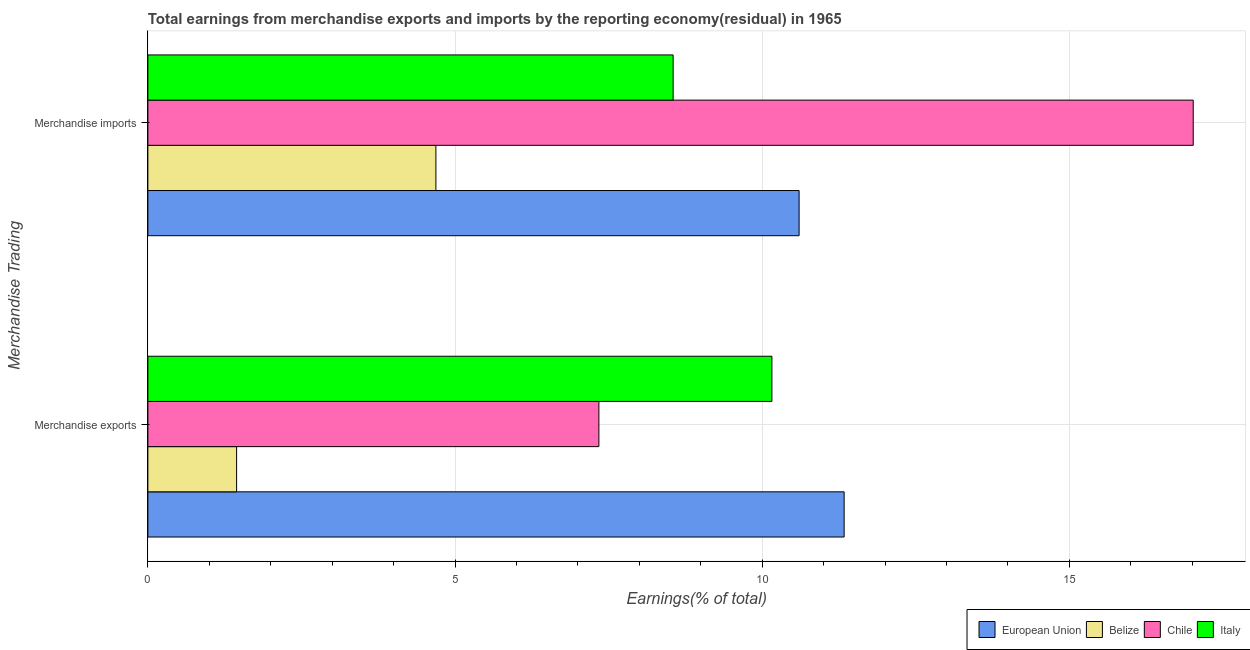How many different coloured bars are there?
Provide a short and direct response. 4. Are the number of bars on each tick of the Y-axis equal?
Make the answer very short. Yes. How many bars are there on the 2nd tick from the top?
Ensure brevity in your answer.  4. What is the label of the 1st group of bars from the top?
Your answer should be compact. Merchandise imports. What is the earnings from merchandise exports in Italy?
Offer a terse response. 10.16. Across all countries, what is the maximum earnings from merchandise imports?
Make the answer very short. 17.02. Across all countries, what is the minimum earnings from merchandise exports?
Keep it short and to the point. 1.44. In which country was the earnings from merchandise exports maximum?
Your answer should be compact. European Union. In which country was the earnings from merchandise imports minimum?
Your answer should be compact. Belize. What is the total earnings from merchandise imports in the graph?
Provide a succinct answer. 40.86. What is the difference between the earnings from merchandise imports in European Union and that in Italy?
Your response must be concise. 2.05. What is the difference between the earnings from merchandise imports in Chile and the earnings from merchandise exports in European Union?
Give a very brief answer. 5.68. What is the average earnings from merchandise exports per country?
Ensure brevity in your answer.  7.57. What is the difference between the earnings from merchandise imports and earnings from merchandise exports in Chile?
Provide a short and direct response. 9.68. In how many countries, is the earnings from merchandise exports greater than 9 %?
Provide a succinct answer. 2. What is the ratio of the earnings from merchandise imports in Belize to that in Italy?
Offer a terse response. 0.55. Is the earnings from merchandise imports in European Union less than that in Chile?
Offer a terse response. Yes. What does the 3rd bar from the top in Merchandise exports represents?
Ensure brevity in your answer.  Belize. What does the 2nd bar from the bottom in Merchandise imports represents?
Your answer should be very brief. Belize. How many bars are there?
Ensure brevity in your answer.  8. Are all the bars in the graph horizontal?
Give a very brief answer. Yes. Are the values on the major ticks of X-axis written in scientific E-notation?
Keep it short and to the point. No. Does the graph contain any zero values?
Offer a terse response. No. Where does the legend appear in the graph?
Give a very brief answer. Bottom right. How many legend labels are there?
Offer a very short reply. 4. What is the title of the graph?
Your response must be concise. Total earnings from merchandise exports and imports by the reporting economy(residual) in 1965. What is the label or title of the X-axis?
Your answer should be very brief. Earnings(% of total). What is the label or title of the Y-axis?
Provide a succinct answer. Merchandise Trading. What is the Earnings(% of total) of European Union in Merchandise exports?
Your answer should be compact. 11.33. What is the Earnings(% of total) in Belize in Merchandise exports?
Make the answer very short. 1.44. What is the Earnings(% of total) in Chile in Merchandise exports?
Your answer should be very brief. 7.34. What is the Earnings(% of total) of Italy in Merchandise exports?
Provide a succinct answer. 10.16. What is the Earnings(% of total) of European Union in Merchandise imports?
Your response must be concise. 10.6. What is the Earnings(% of total) of Belize in Merchandise imports?
Your answer should be compact. 4.69. What is the Earnings(% of total) of Chile in Merchandise imports?
Your answer should be compact. 17.02. What is the Earnings(% of total) of Italy in Merchandise imports?
Offer a very short reply. 8.55. Across all Merchandise Trading, what is the maximum Earnings(% of total) of European Union?
Make the answer very short. 11.33. Across all Merchandise Trading, what is the maximum Earnings(% of total) in Belize?
Your response must be concise. 4.69. Across all Merchandise Trading, what is the maximum Earnings(% of total) in Chile?
Give a very brief answer. 17.02. Across all Merchandise Trading, what is the maximum Earnings(% of total) of Italy?
Make the answer very short. 10.16. Across all Merchandise Trading, what is the minimum Earnings(% of total) of European Union?
Offer a very short reply. 10.6. Across all Merchandise Trading, what is the minimum Earnings(% of total) in Belize?
Give a very brief answer. 1.44. Across all Merchandise Trading, what is the minimum Earnings(% of total) of Chile?
Give a very brief answer. 7.34. Across all Merchandise Trading, what is the minimum Earnings(% of total) in Italy?
Offer a terse response. 8.55. What is the total Earnings(% of total) of European Union in the graph?
Offer a terse response. 21.94. What is the total Earnings(% of total) in Belize in the graph?
Ensure brevity in your answer.  6.13. What is the total Earnings(% of total) of Chile in the graph?
Provide a succinct answer. 24.36. What is the total Earnings(% of total) of Italy in the graph?
Keep it short and to the point. 18.71. What is the difference between the Earnings(% of total) of European Union in Merchandise exports and that in Merchandise imports?
Your response must be concise. 0.73. What is the difference between the Earnings(% of total) in Belize in Merchandise exports and that in Merchandise imports?
Give a very brief answer. -3.24. What is the difference between the Earnings(% of total) in Chile in Merchandise exports and that in Merchandise imports?
Keep it short and to the point. -9.68. What is the difference between the Earnings(% of total) in Italy in Merchandise exports and that in Merchandise imports?
Provide a short and direct response. 1.61. What is the difference between the Earnings(% of total) of European Union in Merchandise exports and the Earnings(% of total) of Belize in Merchandise imports?
Your response must be concise. 6.65. What is the difference between the Earnings(% of total) of European Union in Merchandise exports and the Earnings(% of total) of Chile in Merchandise imports?
Provide a succinct answer. -5.68. What is the difference between the Earnings(% of total) of European Union in Merchandise exports and the Earnings(% of total) of Italy in Merchandise imports?
Offer a terse response. 2.78. What is the difference between the Earnings(% of total) of Belize in Merchandise exports and the Earnings(% of total) of Chile in Merchandise imports?
Provide a short and direct response. -15.57. What is the difference between the Earnings(% of total) in Belize in Merchandise exports and the Earnings(% of total) in Italy in Merchandise imports?
Provide a short and direct response. -7.11. What is the difference between the Earnings(% of total) of Chile in Merchandise exports and the Earnings(% of total) of Italy in Merchandise imports?
Provide a short and direct response. -1.21. What is the average Earnings(% of total) in European Union per Merchandise Trading?
Offer a terse response. 10.97. What is the average Earnings(% of total) in Belize per Merchandise Trading?
Your response must be concise. 3.07. What is the average Earnings(% of total) in Chile per Merchandise Trading?
Offer a very short reply. 12.18. What is the average Earnings(% of total) in Italy per Merchandise Trading?
Your answer should be compact. 9.35. What is the difference between the Earnings(% of total) in European Union and Earnings(% of total) in Belize in Merchandise exports?
Provide a short and direct response. 9.89. What is the difference between the Earnings(% of total) of European Union and Earnings(% of total) of Chile in Merchandise exports?
Provide a succinct answer. 3.99. What is the difference between the Earnings(% of total) of European Union and Earnings(% of total) of Italy in Merchandise exports?
Ensure brevity in your answer.  1.18. What is the difference between the Earnings(% of total) of Belize and Earnings(% of total) of Chile in Merchandise exports?
Offer a very short reply. -5.9. What is the difference between the Earnings(% of total) of Belize and Earnings(% of total) of Italy in Merchandise exports?
Give a very brief answer. -8.71. What is the difference between the Earnings(% of total) of Chile and Earnings(% of total) of Italy in Merchandise exports?
Your answer should be very brief. -2.82. What is the difference between the Earnings(% of total) in European Union and Earnings(% of total) in Belize in Merchandise imports?
Ensure brevity in your answer.  5.91. What is the difference between the Earnings(% of total) in European Union and Earnings(% of total) in Chile in Merchandise imports?
Provide a succinct answer. -6.42. What is the difference between the Earnings(% of total) of European Union and Earnings(% of total) of Italy in Merchandise imports?
Your response must be concise. 2.05. What is the difference between the Earnings(% of total) of Belize and Earnings(% of total) of Chile in Merchandise imports?
Give a very brief answer. -12.33. What is the difference between the Earnings(% of total) in Belize and Earnings(% of total) in Italy in Merchandise imports?
Keep it short and to the point. -3.86. What is the difference between the Earnings(% of total) in Chile and Earnings(% of total) in Italy in Merchandise imports?
Provide a short and direct response. 8.47. What is the ratio of the Earnings(% of total) in European Union in Merchandise exports to that in Merchandise imports?
Offer a terse response. 1.07. What is the ratio of the Earnings(% of total) in Belize in Merchandise exports to that in Merchandise imports?
Your response must be concise. 0.31. What is the ratio of the Earnings(% of total) in Chile in Merchandise exports to that in Merchandise imports?
Your response must be concise. 0.43. What is the ratio of the Earnings(% of total) in Italy in Merchandise exports to that in Merchandise imports?
Provide a short and direct response. 1.19. What is the difference between the highest and the second highest Earnings(% of total) in European Union?
Give a very brief answer. 0.73. What is the difference between the highest and the second highest Earnings(% of total) of Belize?
Make the answer very short. 3.24. What is the difference between the highest and the second highest Earnings(% of total) of Chile?
Give a very brief answer. 9.68. What is the difference between the highest and the second highest Earnings(% of total) of Italy?
Your response must be concise. 1.61. What is the difference between the highest and the lowest Earnings(% of total) in European Union?
Make the answer very short. 0.73. What is the difference between the highest and the lowest Earnings(% of total) of Belize?
Your response must be concise. 3.24. What is the difference between the highest and the lowest Earnings(% of total) of Chile?
Make the answer very short. 9.68. What is the difference between the highest and the lowest Earnings(% of total) in Italy?
Give a very brief answer. 1.61. 